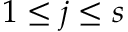Convert formula to latex. <formula><loc_0><loc_0><loc_500><loc_500>1 \leq j \leq s</formula> 